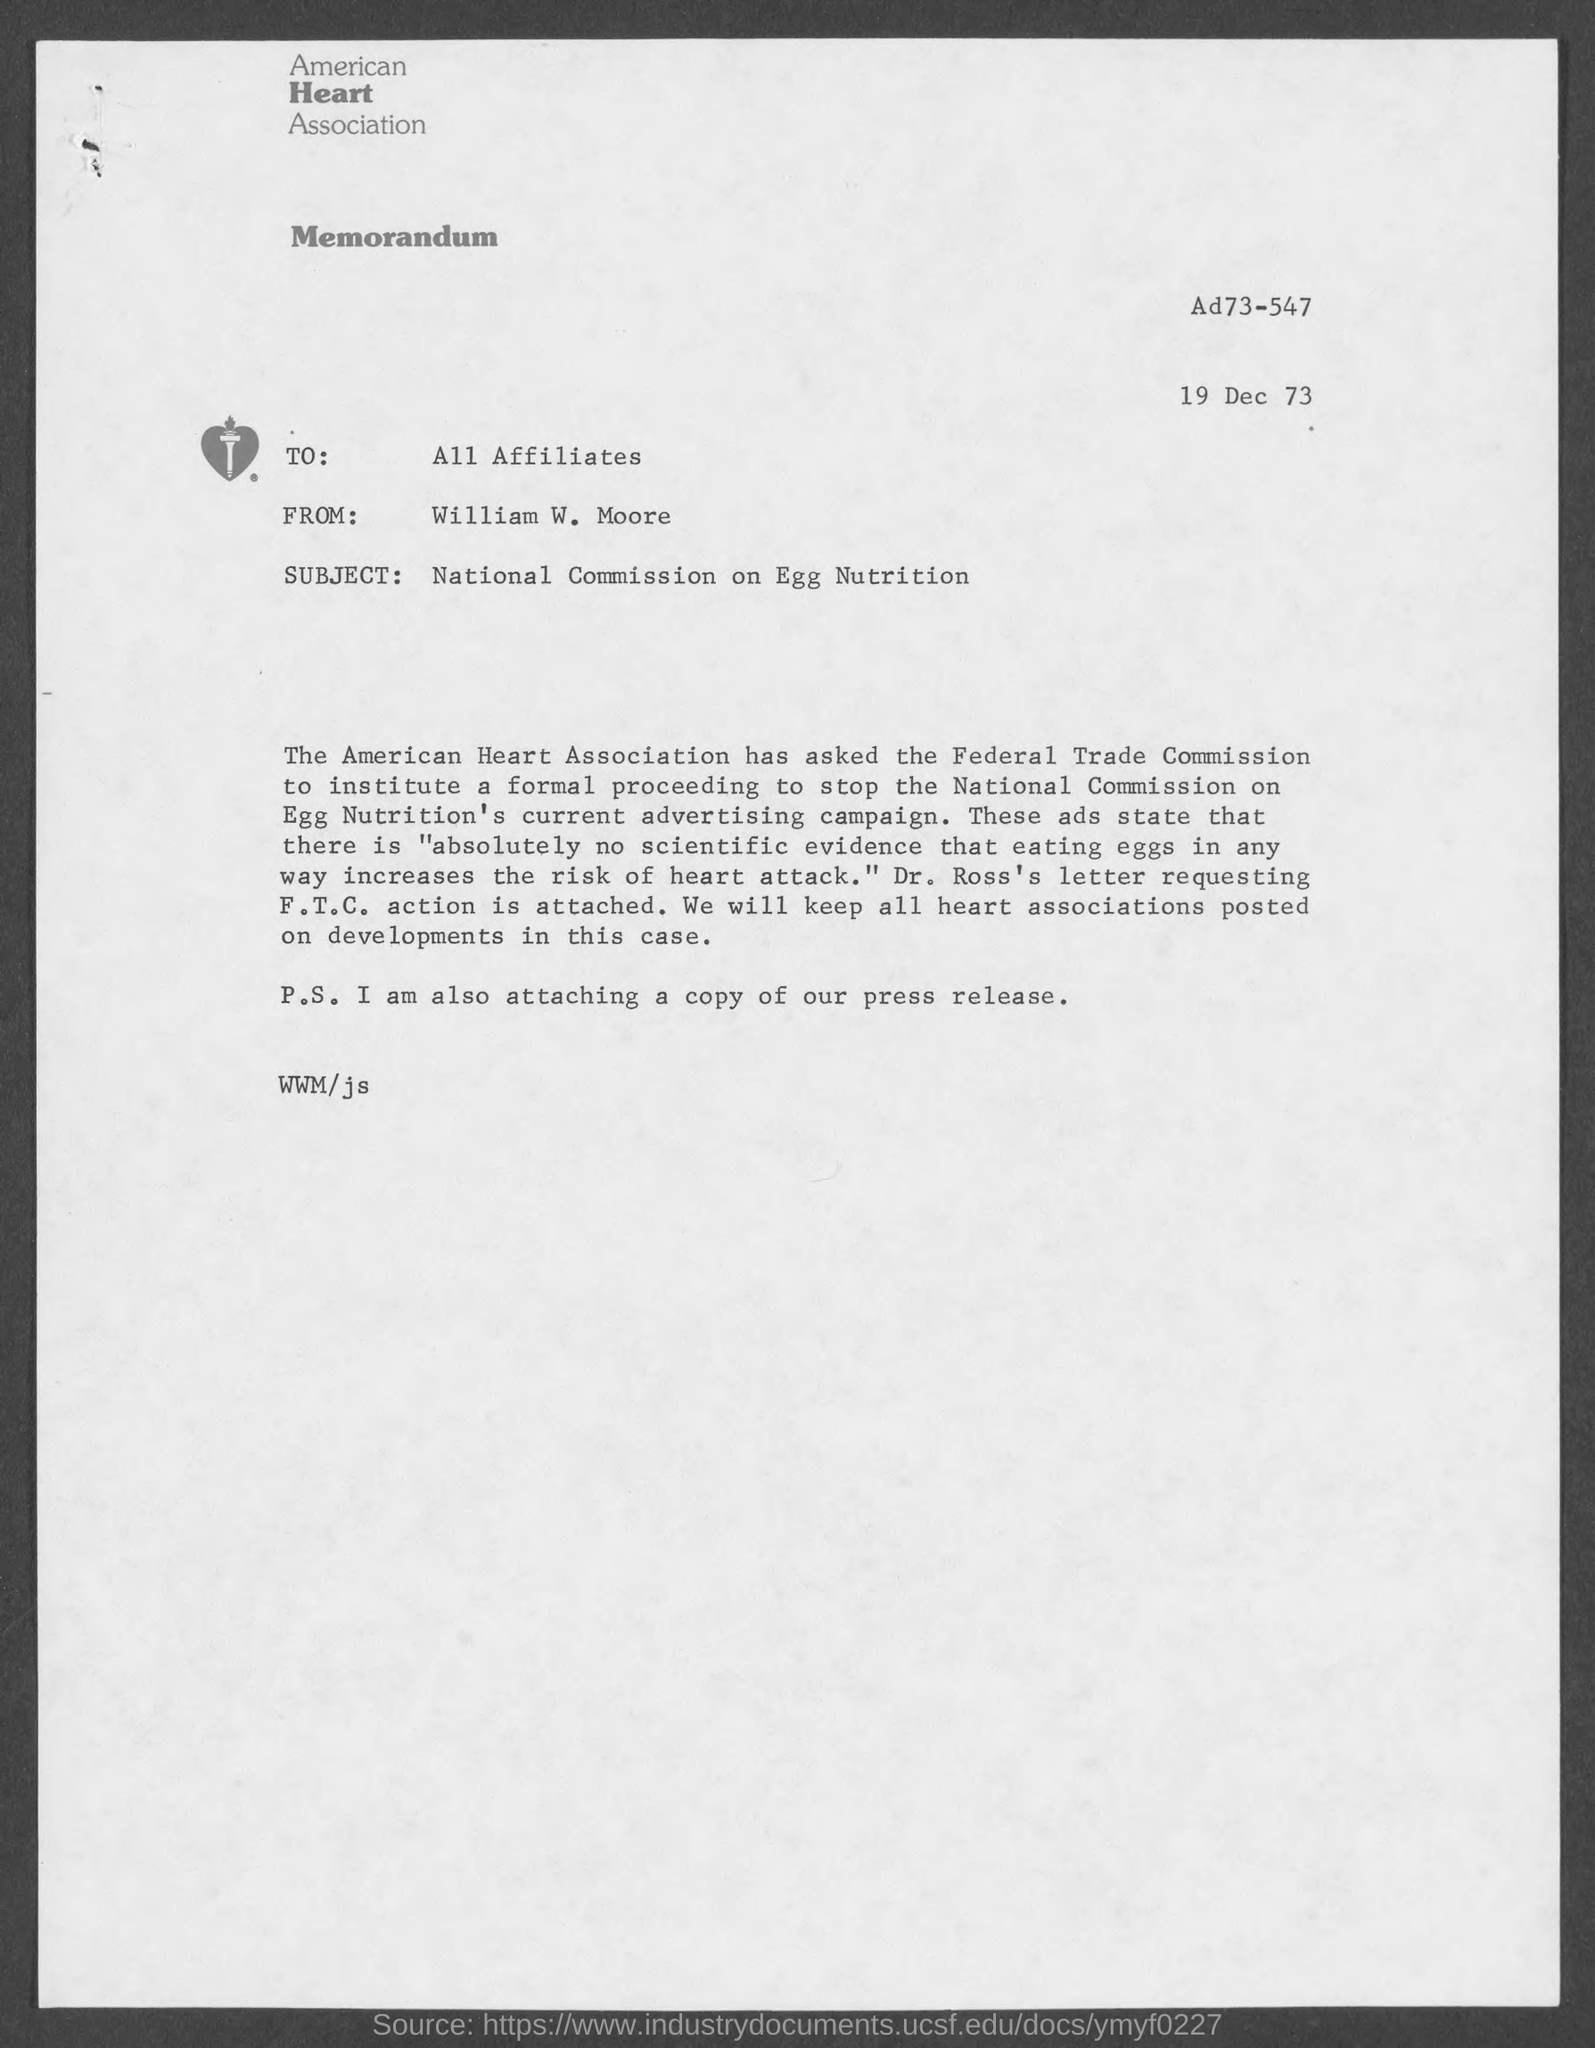Indicate a few pertinent items in this graphic. The association mentioned on the letterhead is the American Heart Association. The subject of this memorandum is the National Commission on Egg Nutrition. The date mentioned in the memorandum is December 19, 1973. The sender of this memorandum is William W. Moore. The memorandum is addressed to all affiliates. 